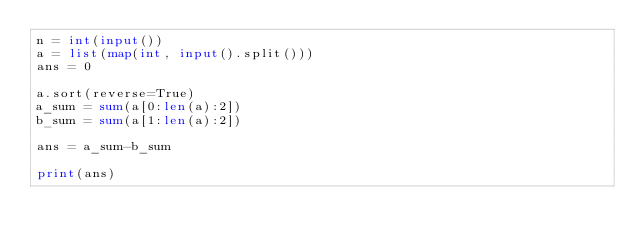<code> <loc_0><loc_0><loc_500><loc_500><_Python_>n = int(input())
a = list(map(int, input().split()))
ans = 0

a.sort(reverse=True)
a_sum = sum(a[0:len(a):2])
b_sum = sum(a[1:len(a):2])

ans = a_sum-b_sum

print(ans)</code> 